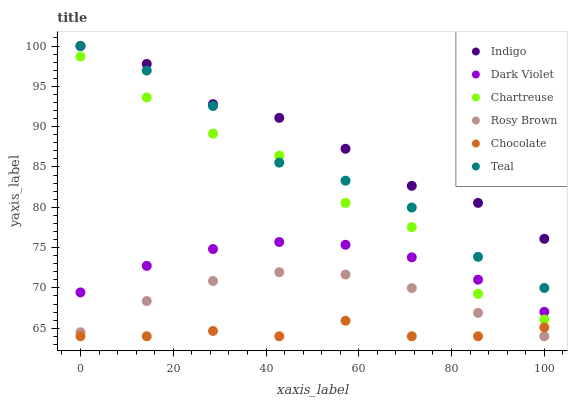Does Chocolate have the minimum area under the curve?
Answer yes or no. Yes. Does Indigo have the maximum area under the curve?
Answer yes or no. Yes. Does Rosy Brown have the minimum area under the curve?
Answer yes or no. No. Does Rosy Brown have the maximum area under the curve?
Answer yes or no. No. Is Rosy Brown the smoothest?
Answer yes or no. Yes. Is Chartreuse the roughest?
Answer yes or no. Yes. Is Dark Violet the smoothest?
Answer yes or no. No. Is Dark Violet the roughest?
Answer yes or no. No. Does Rosy Brown have the lowest value?
Answer yes or no. Yes. Does Dark Violet have the lowest value?
Answer yes or no. No. Does Teal have the highest value?
Answer yes or no. Yes. Does Rosy Brown have the highest value?
Answer yes or no. No. Is Chartreuse less than Indigo?
Answer yes or no. Yes. Is Teal greater than Chocolate?
Answer yes or no. Yes. Does Teal intersect Chartreuse?
Answer yes or no. Yes. Is Teal less than Chartreuse?
Answer yes or no. No. Is Teal greater than Chartreuse?
Answer yes or no. No. Does Chartreuse intersect Indigo?
Answer yes or no. No. 